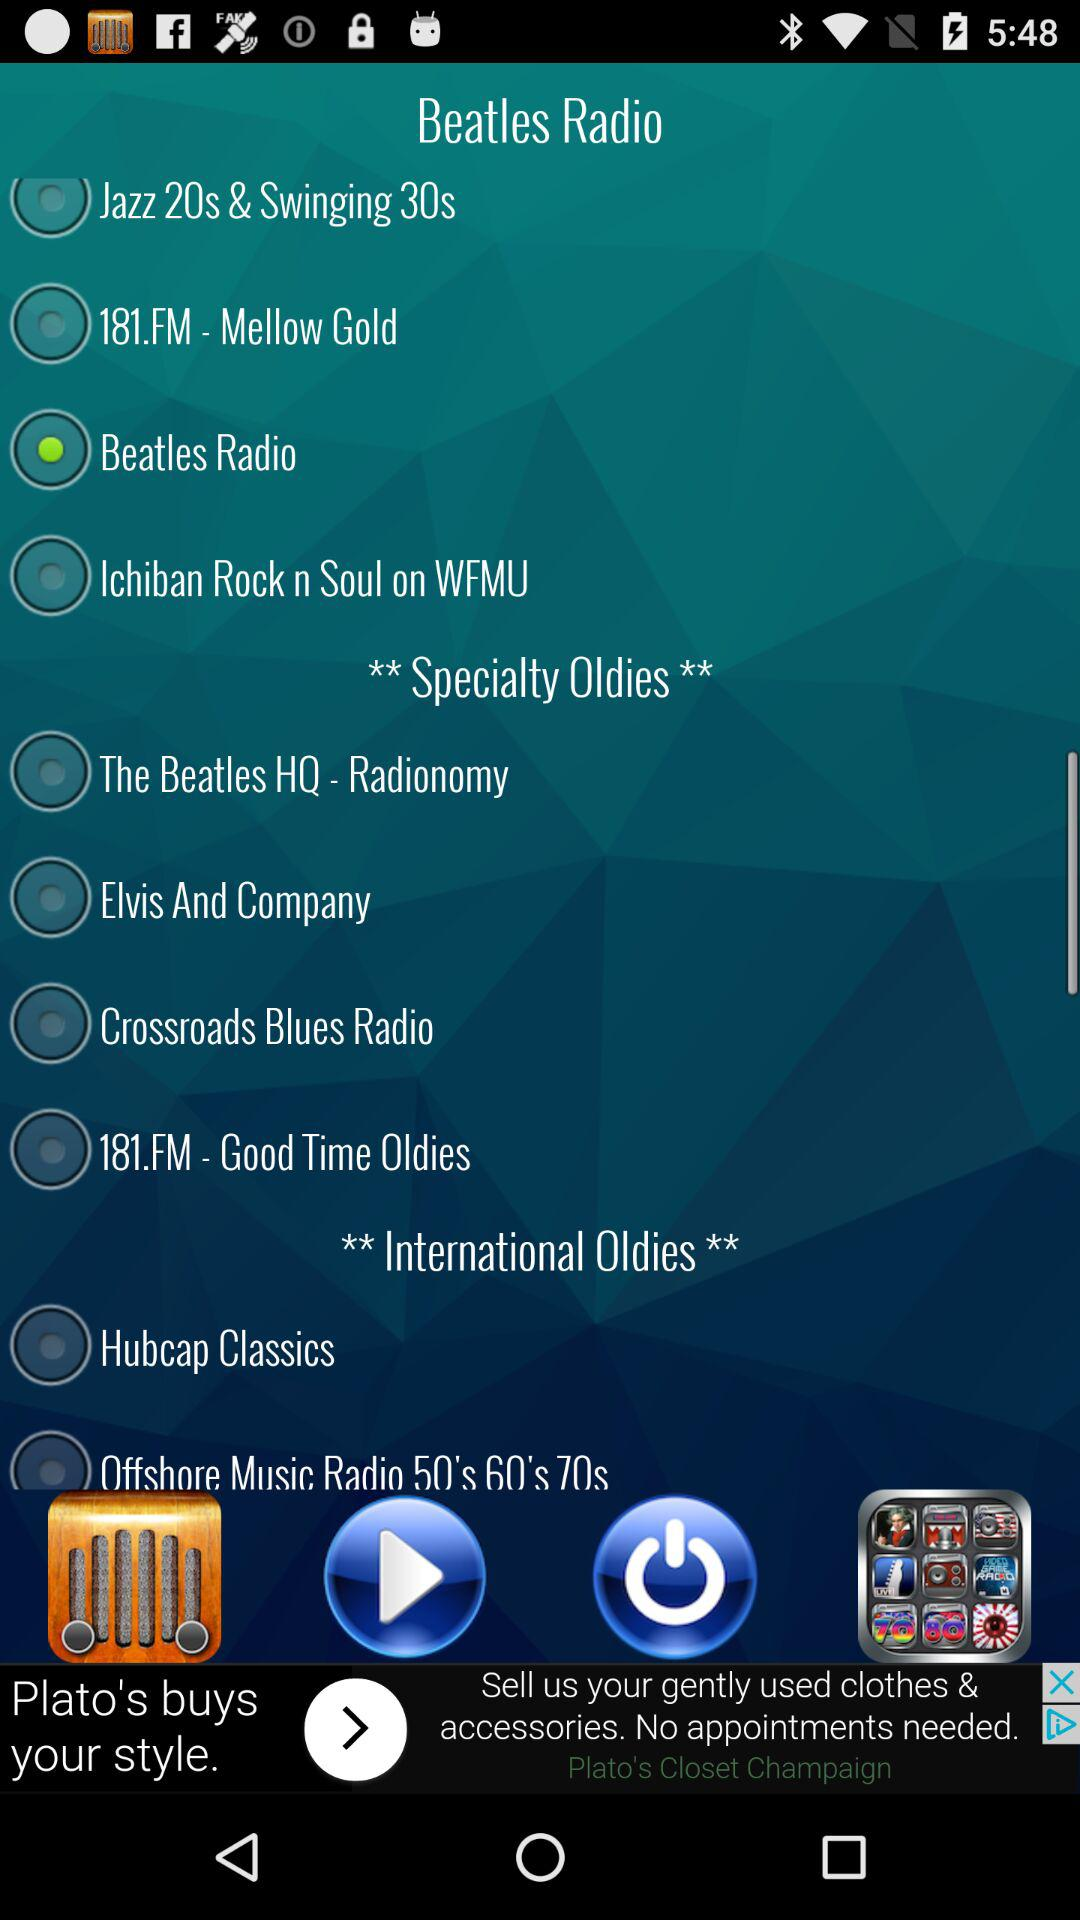What's the selected radio station? The selected radio station is "Beatles Radio". 